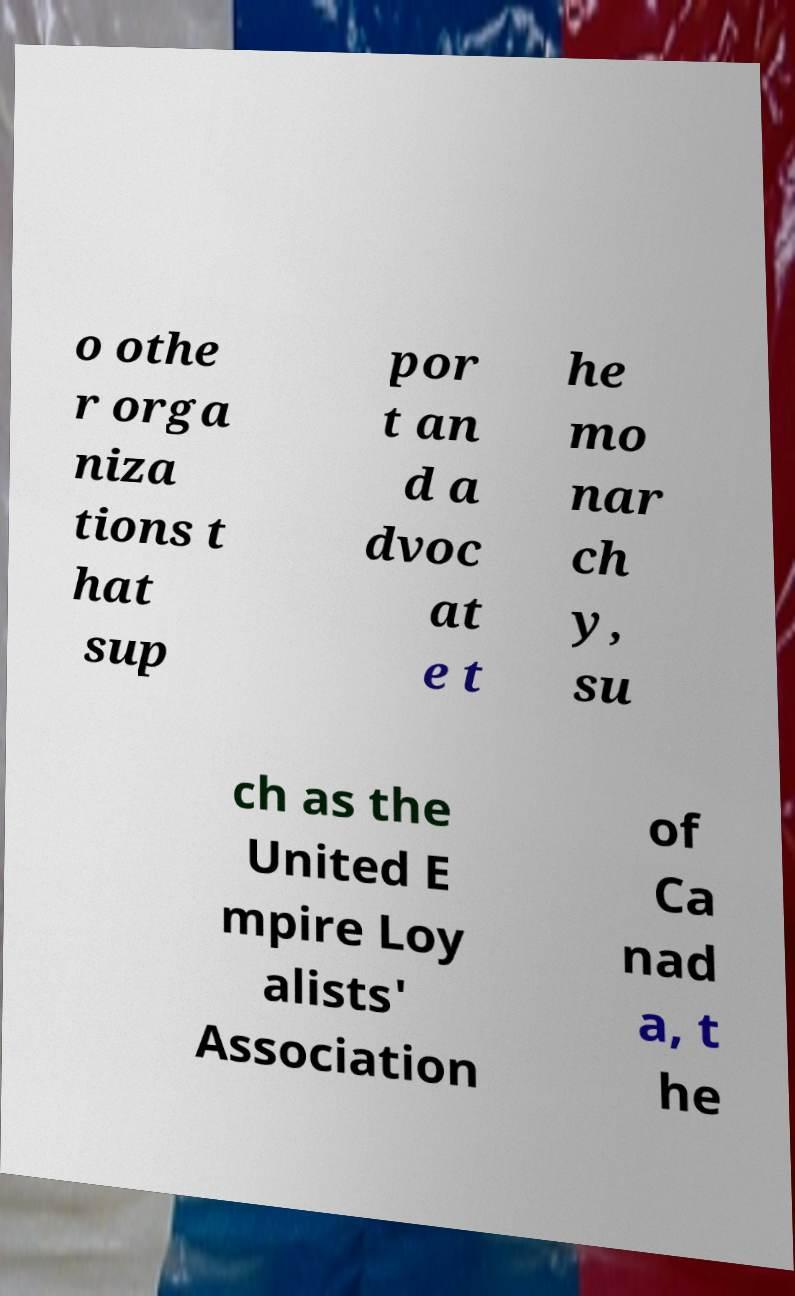Could you assist in decoding the text presented in this image and type it out clearly? o othe r orga niza tions t hat sup por t an d a dvoc at e t he mo nar ch y, su ch as the United E mpire Loy alists' Association of Ca nad a, t he 